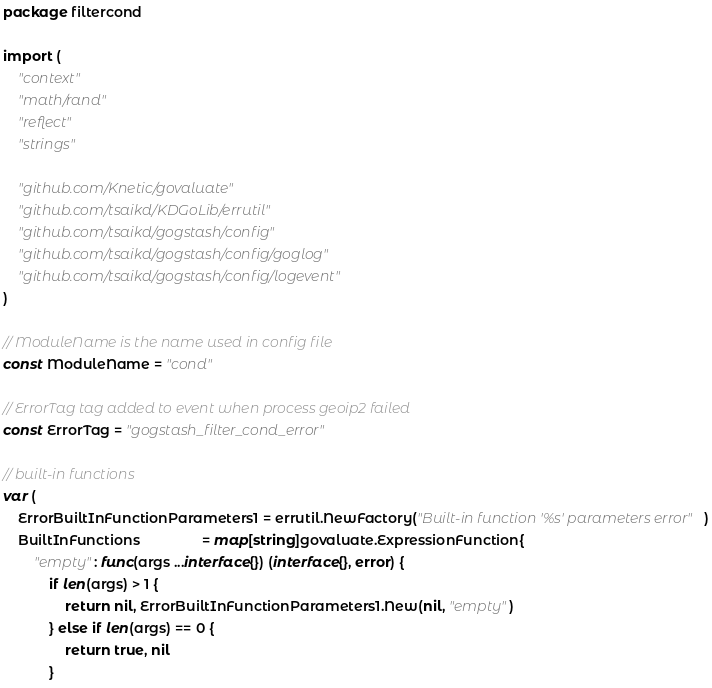<code> <loc_0><loc_0><loc_500><loc_500><_Go_>package filtercond

import (
	"context"
	"math/rand"
	"reflect"
	"strings"

	"github.com/Knetic/govaluate"
	"github.com/tsaikd/KDGoLib/errutil"
	"github.com/tsaikd/gogstash/config"
	"github.com/tsaikd/gogstash/config/goglog"
	"github.com/tsaikd/gogstash/config/logevent"
)

// ModuleName is the name used in config file
const ModuleName = "cond"

// ErrorTag tag added to event when process geoip2 failed
const ErrorTag = "gogstash_filter_cond_error"

// built-in functions
var (
	ErrorBuiltInFunctionParameters1 = errutil.NewFactory("Built-in function '%s' parameters error")
	BuiltInFunctions                = map[string]govaluate.ExpressionFunction{
		"empty": func(args ...interface{}) (interface{}, error) {
			if len(args) > 1 {
				return nil, ErrorBuiltInFunctionParameters1.New(nil, "empty")
			} else if len(args) == 0 {
				return true, nil
			}</code> 